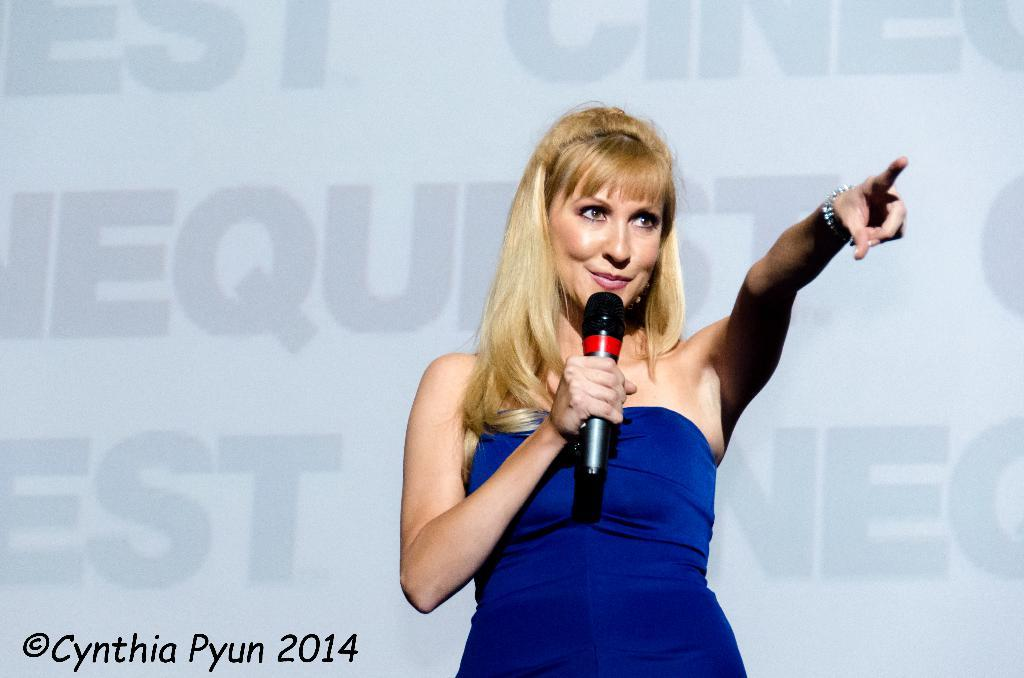Who is the main subject in the image? There is a woman in the image. What is the woman doing in the image? The woman is standing in the image. What object is the woman holding in her hand? The woman is holding a mic in her hand. Are there any fairies visible in the image? No, there are no fairies present in the image. 